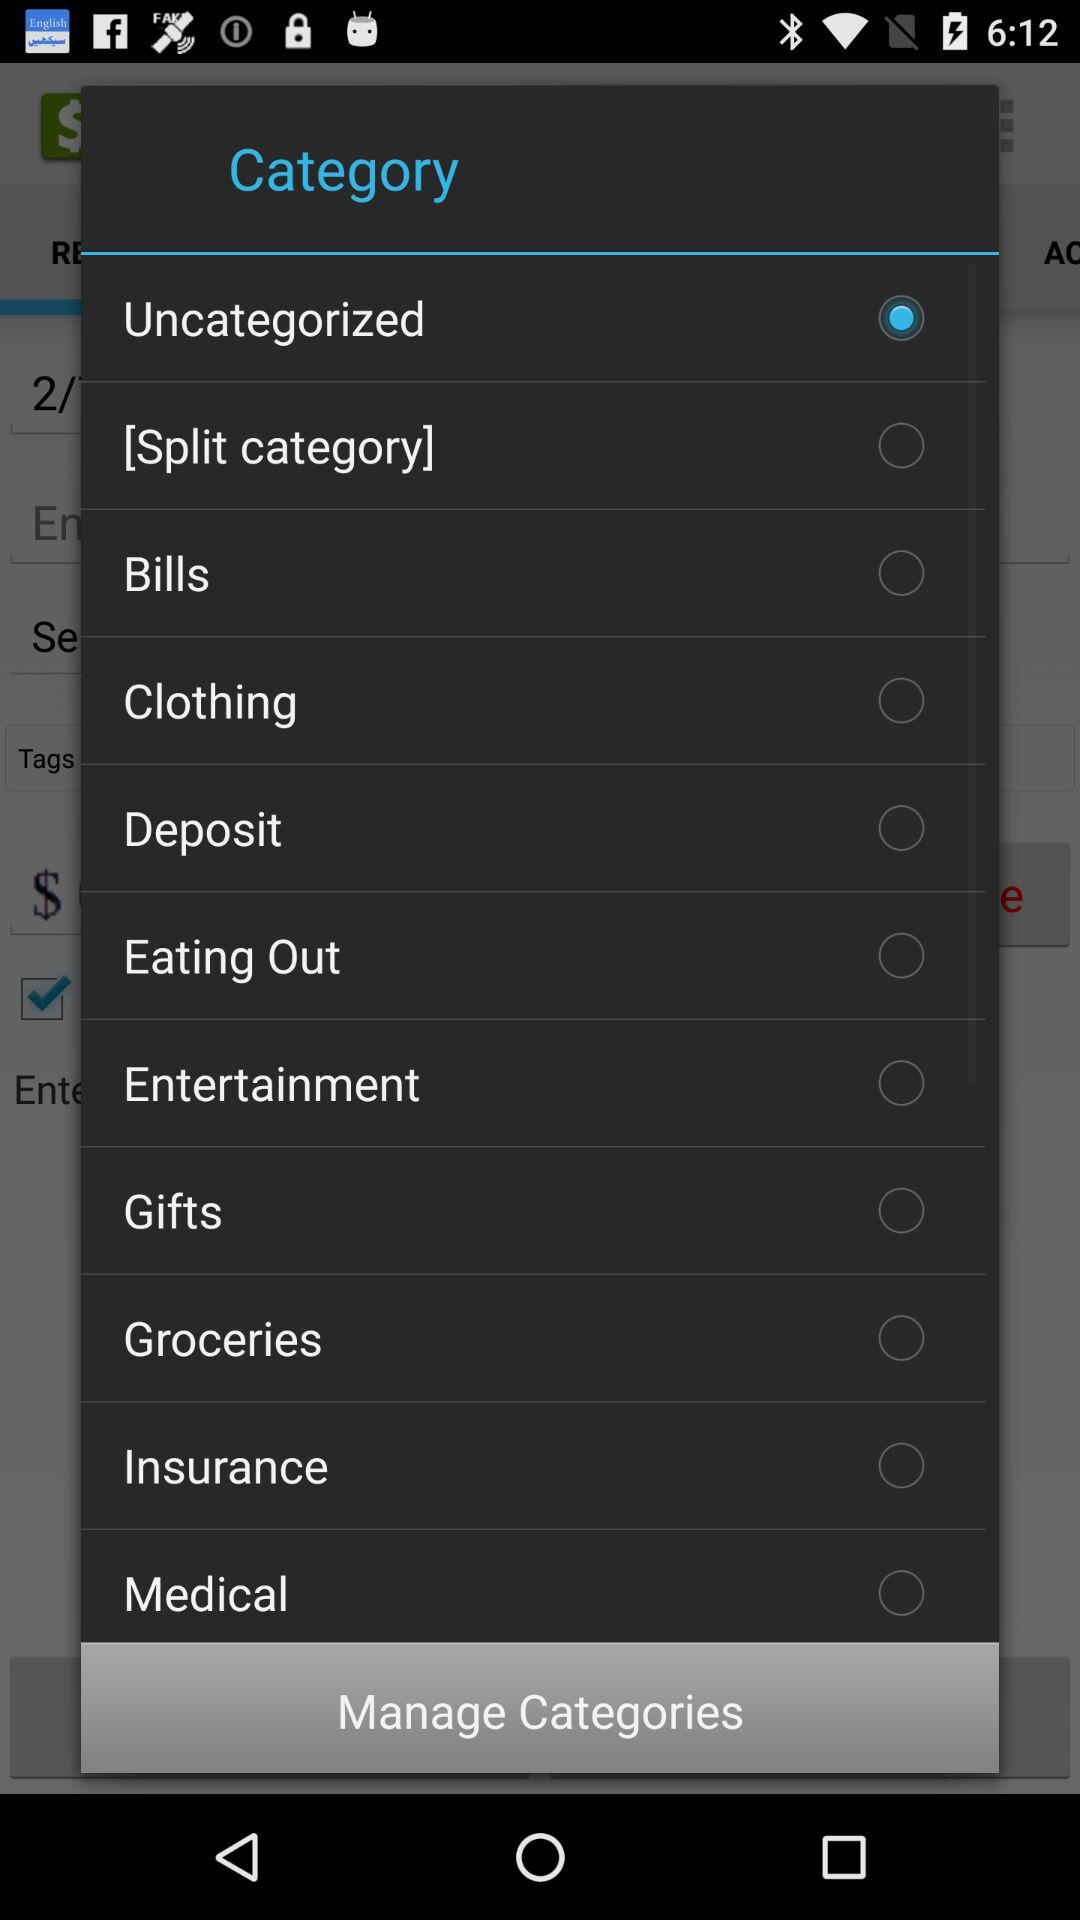Which category is selected? The selected category is "Uncategorized". 